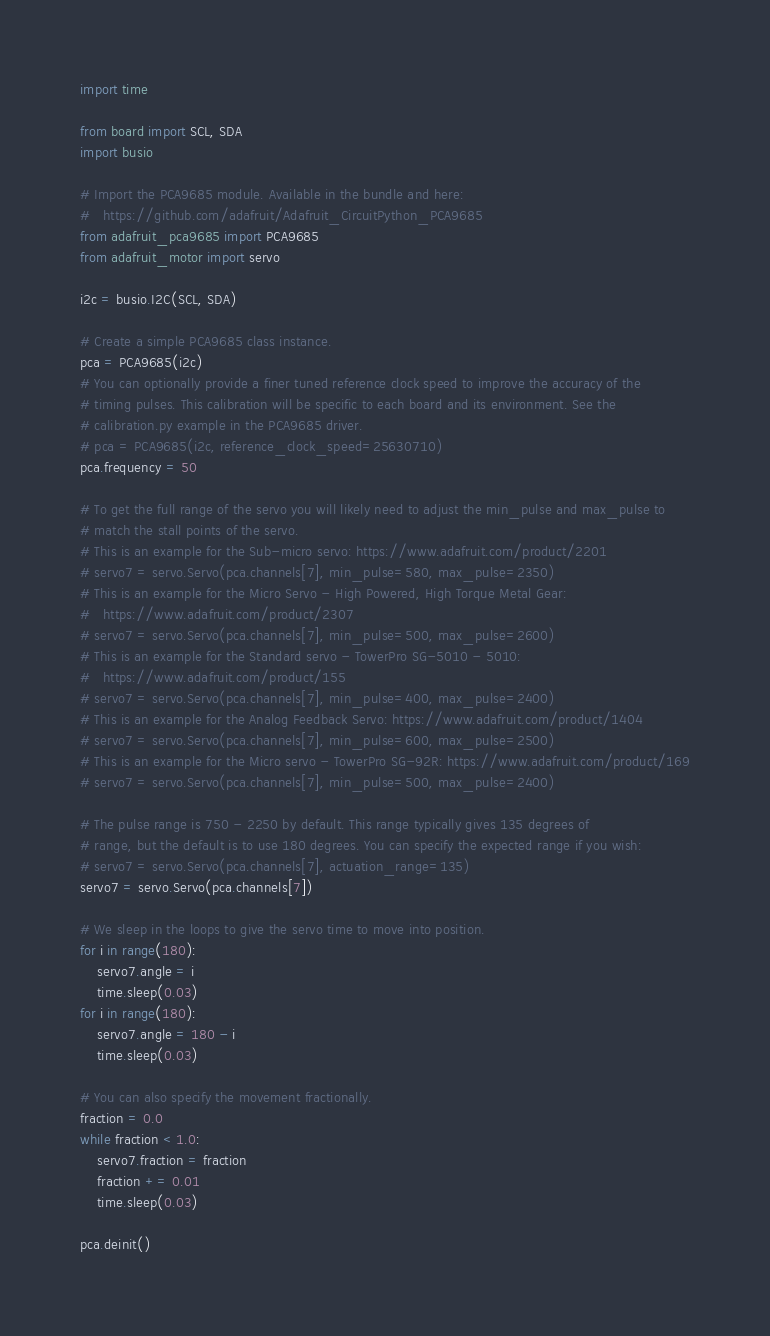<code> <loc_0><loc_0><loc_500><loc_500><_Python_>import time

from board import SCL, SDA
import busio

# Import the PCA9685 module. Available in the bundle and here:
#   https://github.com/adafruit/Adafruit_CircuitPython_PCA9685
from adafruit_pca9685 import PCA9685
from adafruit_motor import servo

i2c = busio.I2C(SCL, SDA)

# Create a simple PCA9685 class instance.
pca = PCA9685(i2c)
# You can optionally provide a finer tuned reference clock speed to improve the accuracy of the
# timing pulses. This calibration will be specific to each board and its environment. See the
# calibration.py example in the PCA9685 driver.
# pca = PCA9685(i2c, reference_clock_speed=25630710)
pca.frequency = 50

# To get the full range of the servo you will likely need to adjust the min_pulse and max_pulse to
# match the stall points of the servo.
# This is an example for the Sub-micro servo: https://www.adafruit.com/product/2201
# servo7 = servo.Servo(pca.channels[7], min_pulse=580, max_pulse=2350)
# This is an example for the Micro Servo - High Powered, High Torque Metal Gear:
#   https://www.adafruit.com/product/2307
# servo7 = servo.Servo(pca.channels[7], min_pulse=500, max_pulse=2600)
# This is an example for the Standard servo - TowerPro SG-5010 - 5010:
#   https://www.adafruit.com/product/155
# servo7 = servo.Servo(pca.channels[7], min_pulse=400, max_pulse=2400)
# This is an example for the Analog Feedback Servo: https://www.adafruit.com/product/1404
# servo7 = servo.Servo(pca.channels[7], min_pulse=600, max_pulse=2500)
# This is an example for the Micro servo - TowerPro SG-92R: https://www.adafruit.com/product/169
# servo7 = servo.Servo(pca.channels[7], min_pulse=500, max_pulse=2400)

# The pulse range is 750 - 2250 by default. This range typically gives 135 degrees of
# range, but the default is to use 180 degrees. You can specify the expected range if you wish:
# servo7 = servo.Servo(pca.channels[7], actuation_range=135)
servo7 = servo.Servo(pca.channels[7])

# We sleep in the loops to give the servo time to move into position.
for i in range(180):
    servo7.angle = i
    time.sleep(0.03)
for i in range(180):
    servo7.angle = 180 - i
    time.sleep(0.03)

# You can also specify the movement fractionally.
fraction = 0.0
while fraction < 1.0:
    servo7.fraction = fraction
    fraction += 0.01
    time.sleep(0.03)

pca.deinit()
</code> 